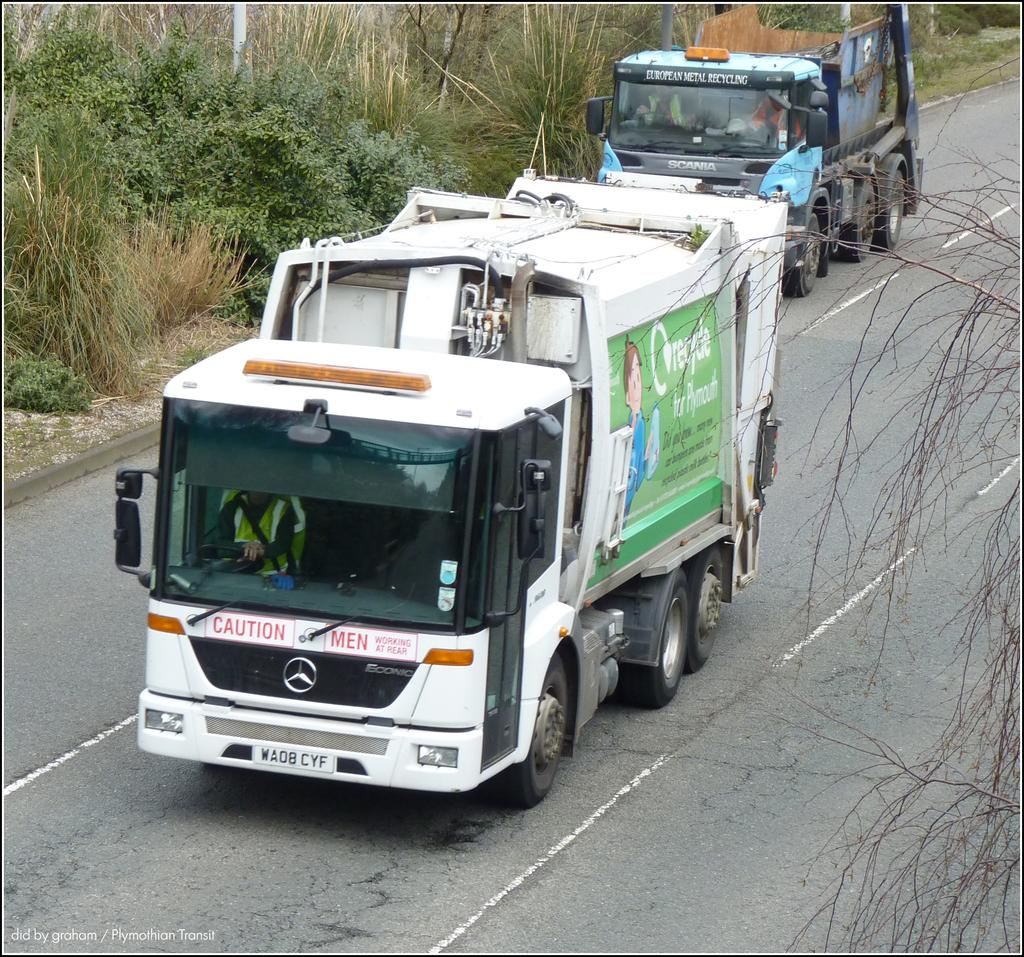What is happening on the road in the image? There are vehicles passing on the road in the image. What type of natural elements can be seen in the image? Trees and grass are visible in the image. How is the image framed? The image has borders. Where is the text located in the image? There is text in the bottom left corner of the image. What type of drum can be seen in the image? There is no drum present in the image. Is the image taken during winter? The provided facts do not mention any seasonal context, so it cannot be determined if the image was taken during winter. 